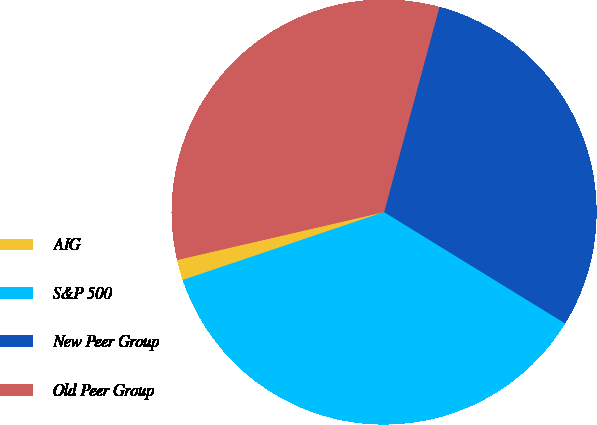Convert chart. <chart><loc_0><loc_0><loc_500><loc_500><pie_chart><fcel>AIG<fcel>S&P 500<fcel>New Peer Group<fcel>Old Peer Group<nl><fcel>1.56%<fcel>36.04%<fcel>29.58%<fcel>32.81%<nl></chart> 